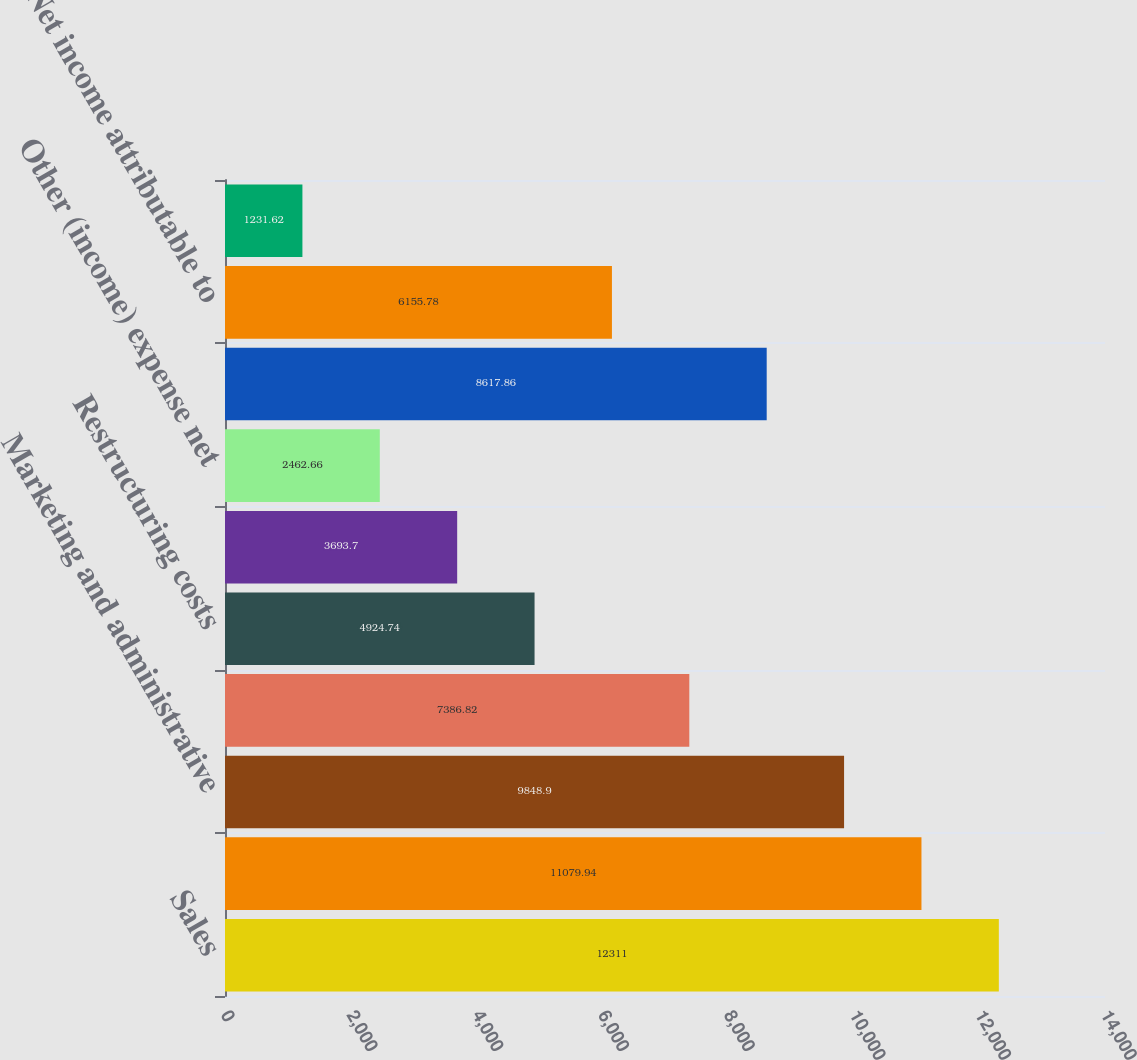Convert chart to OTSL. <chart><loc_0><loc_0><loc_500><loc_500><bar_chart><fcel>Sales<fcel>Materials and production<fcel>Marketing and administrative<fcel>Research and development<fcel>Restructuring costs<fcel>Equity income from affiliates<fcel>Other (income) expense net<fcel>Income before taxes<fcel>Net income attributable to<fcel>Basic earnings per common<nl><fcel>12311<fcel>11079.9<fcel>9848.9<fcel>7386.82<fcel>4924.74<fcel>3693.7<fcel>2462.66<fcel>8617.86<fcel>6155.78<fcel>1231.62<nl></chart> 